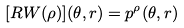<formula> <loc_0><loc_0><loc_500><loc_500>[ R W ( \rho ) ] ( \theta , r ) = p ^ { \rho } ( \theta , r )</formula> 